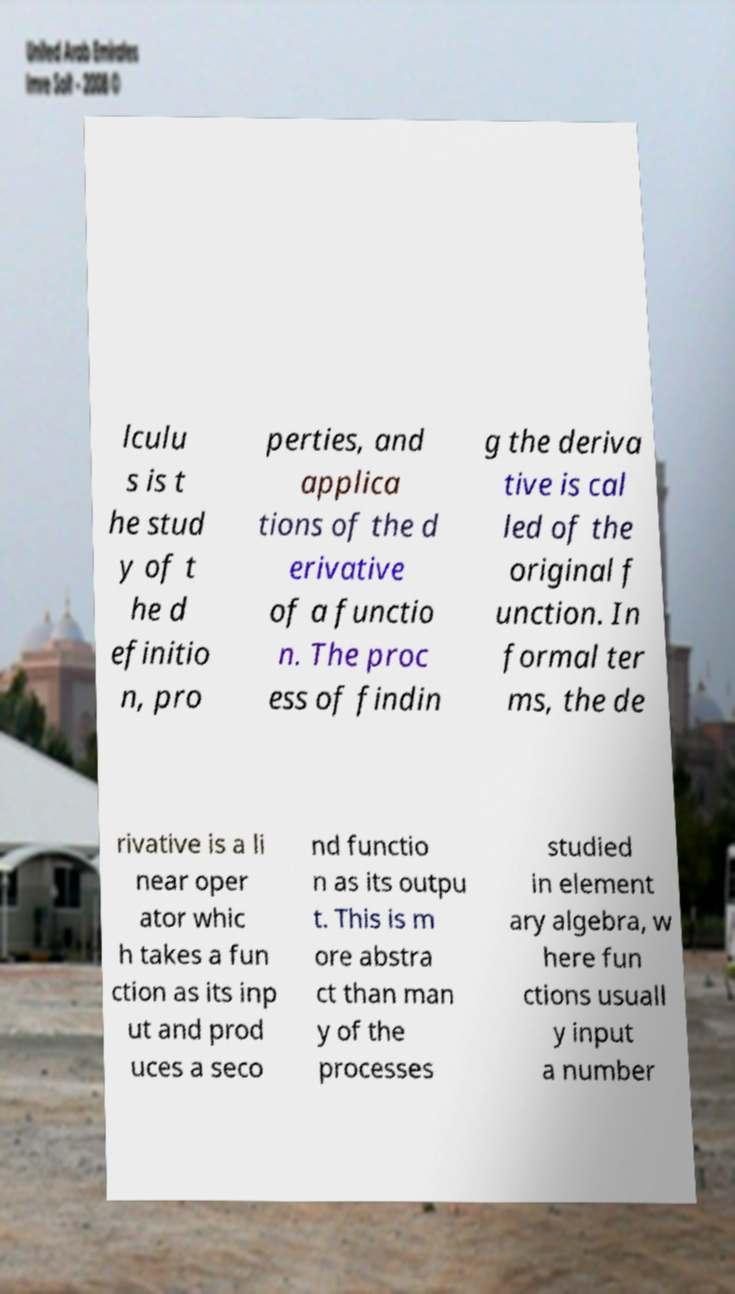There's text embedded in this image that I need extracted. Can you transcribe it verbatim? lculu s is t he stud y of t he d efinitio n, pro perties, and applica tions of the d erivative of a functio n. The proc ess of findin g the deriva tive is cal led of the original f unction. In formal ter ms, the de rivative is a li near oper ator whic h takes a fun ction as its inp ut and prod uces a seco nd functio n as its outpu t. This is m ore abstra ct than man y of the processes studied in element ary algebra, w here fun ctions usuall y input a number 